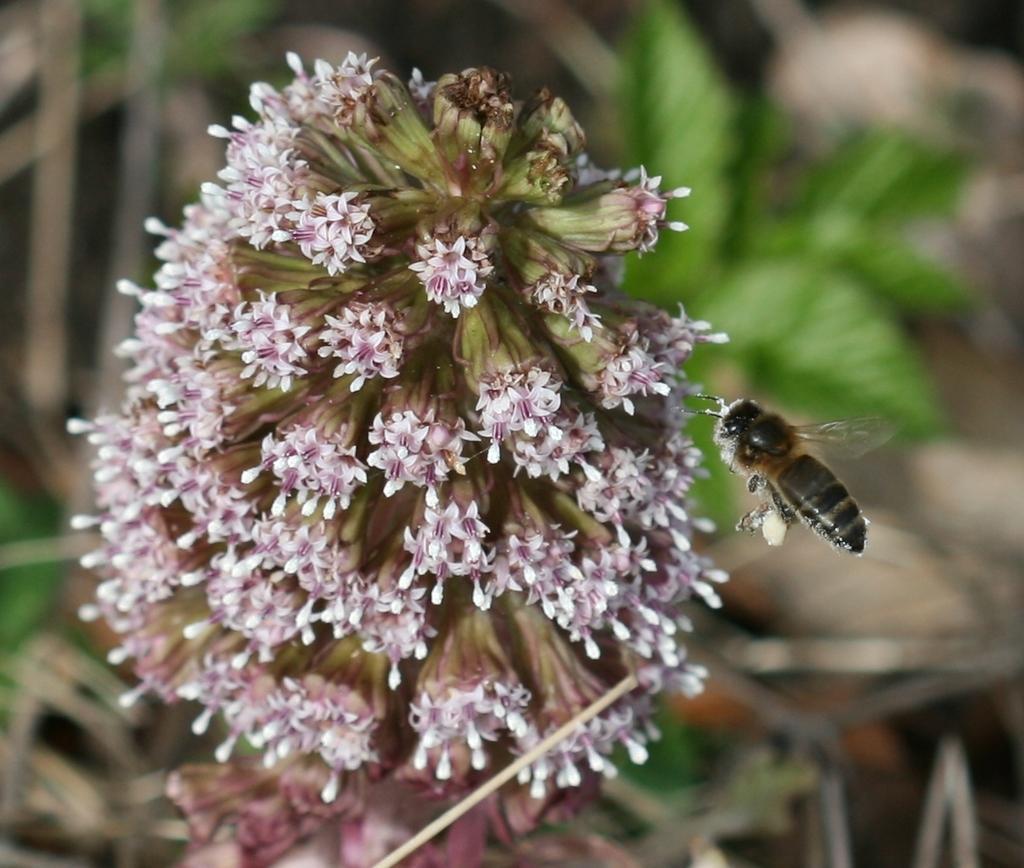How would you summarize this image in a sentence or two? In the center of the image we can see honey bee and flowers. 